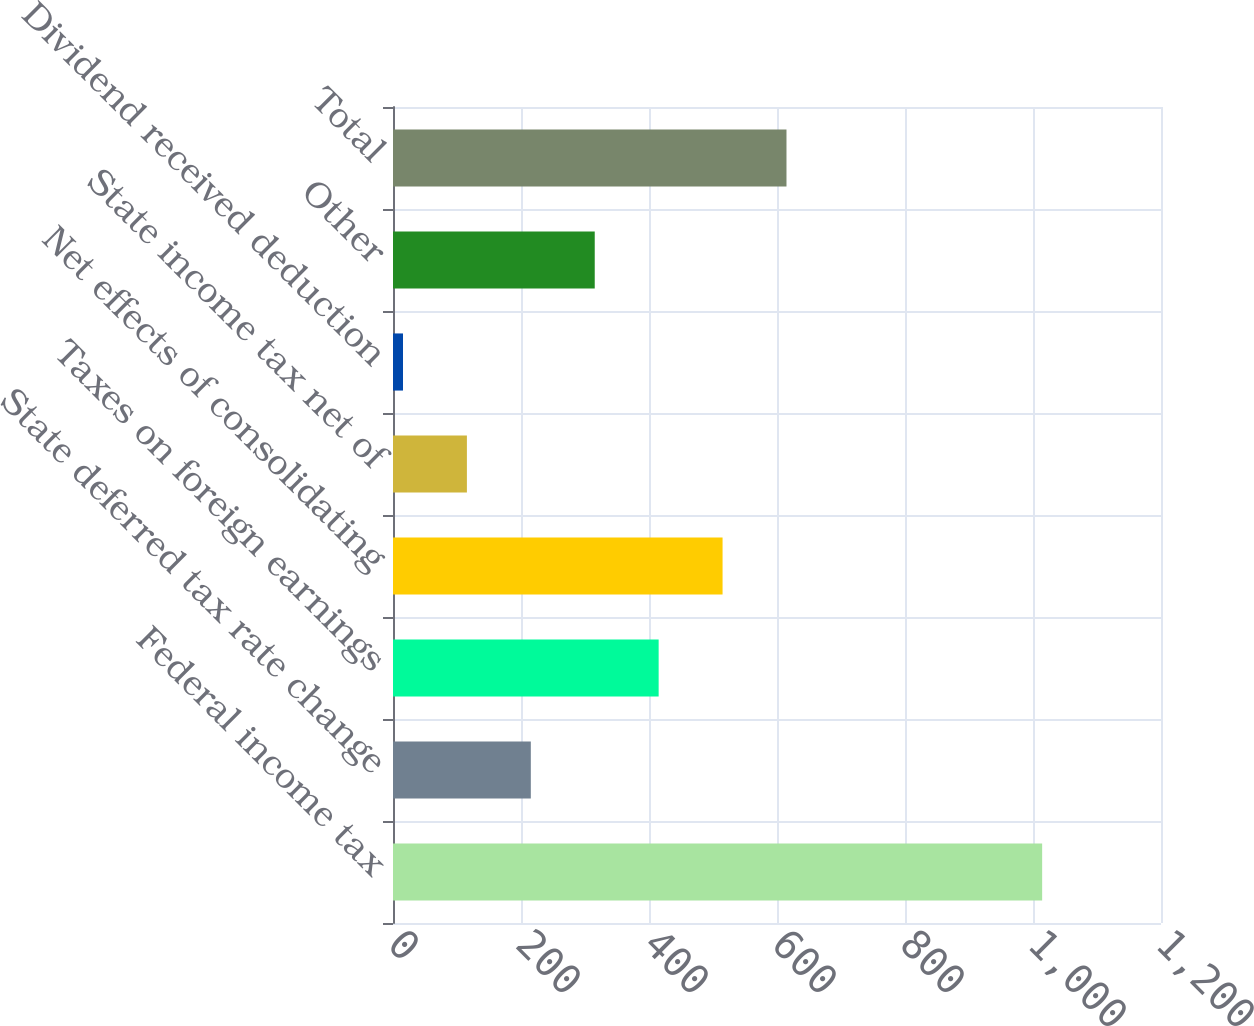<chart> <loc_0><loc_0><loc_500><loc_500><bar_chart><fcel>Federal income tax<fcel>State deferred tax rate change<fcel>Taxes on foreign earnings<fcel>Net effects of consolidating<fcel>State income tax net of<fcel>Dividend received deduction<fcel>Other<fcel>Total<nl><fcel>1014.3<fcel>215.34<fcel>415.08<fcel>514.95<fcel>115.47<fcel>15.6<fcel>315.21<fcel>614.82<nl></chart> 